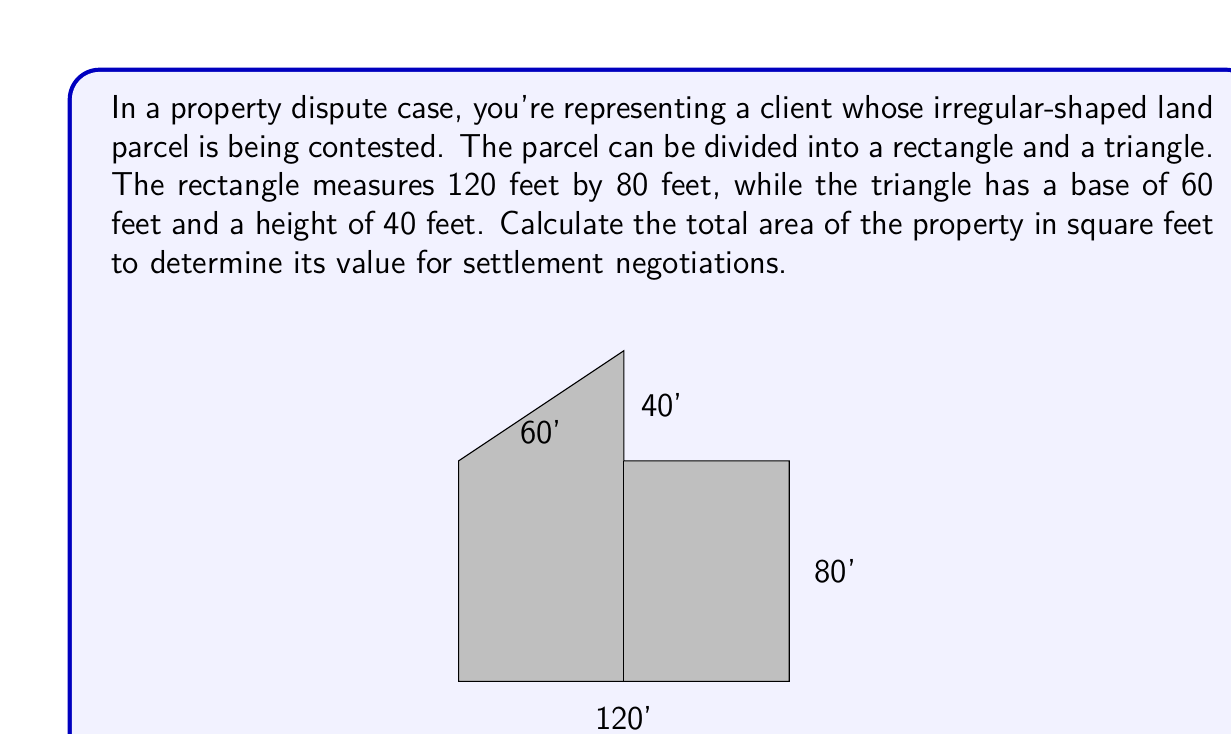Teach me how to tackle this problem. To calculate the total area of the irregular-shaped property, we need to:

1. Calculate the area of the rectangle:
   $$A_{rectangle} = length \times width$$
   $$A_{rectangle} = 120 \text{ ft} \times 80 \text{ ft} = 9,600 \text{ sq ft}$$

2. Calculate the area of the triangle:
   $$A_{triangle} = \frac{1}{2} \times base \times height$$
   $$A_{triangle} = \frac{1}{2} \times 60 \text{ ft} \times 40 \text{ ft} = 1,200 \text{ sq ft}$$

3. Sum the areas of both shapes to get the total area:
   $$A_{total} = A_{rectangle} + A_{triangle}$$
   $$A_{total} = 9,600 \text{ sq ft} + 1,200 \text{ sq ft} = 10,800 \text{ sq ft}$$

Therefore, the total area of the property is 10,800 square feet.
Answer: 10,800 sq ft 